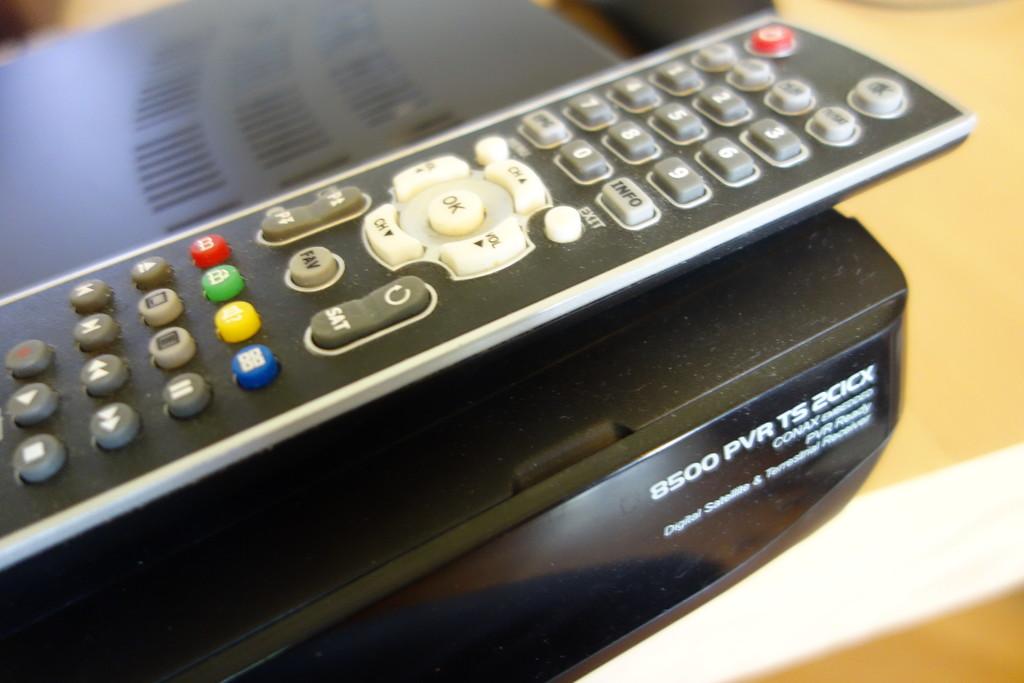What model number is the electronic device?
Provide a short and direct response. 8500 pvr ts 2cicx. What is one of the buttons on the device?
Offer a very short reply. Info. 